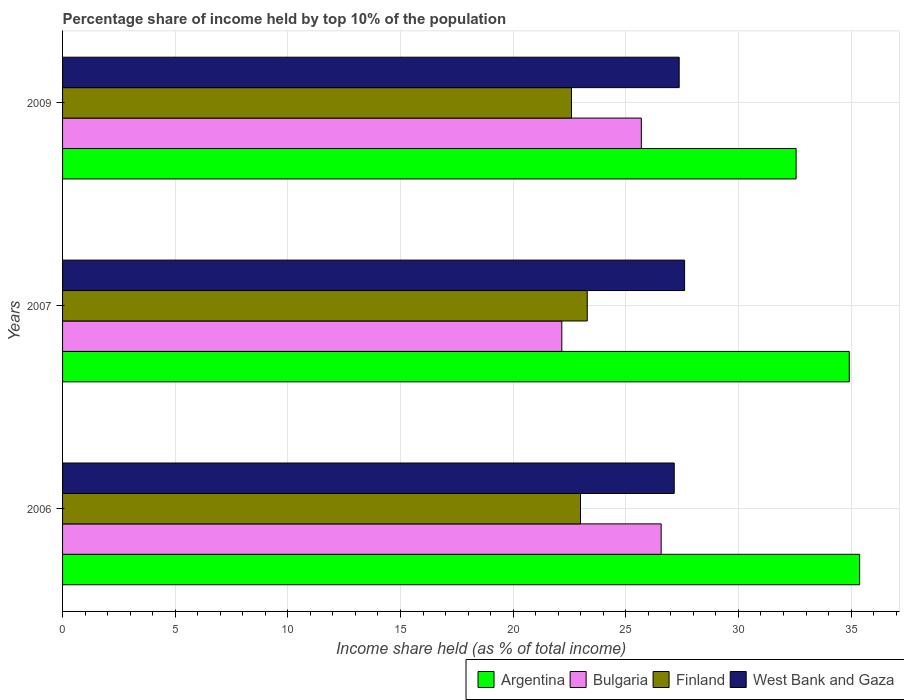How many different coloured bars are there?
Provide a succinct answer. 4. How many groups of bars are there?
Your response must be concise. 3. Are the number of bars per tick equal to the number of legend labels?
Provide a succinct answer. Yes. What is the label of the 3rd group of bars from the top?
Offer a terse response. 2006. What is the percentage share of income held by top 10% of the population in Argentina in 2006?
Your answer should be very brief. 35.38. Across all years, what is the maximum percentage share of income held by top 10% of the population in Argentina?
Your response must be concise. 35.38. Across all years, what is the minimum percentage share of income held by top 10% of the population in Finland?
Ensure brevity in your answer.  22.59. In which year was the percentage share of income held by top 10% of the population in West Bank and Gaza maximum?
Provide a succinct answer. 2007. In which year was the percentage share of income held by top 10% of the population in Finland minimum?
Offer a terse response. 2009. What is the total percentage share of income held by top 10% of the population in West Bank and Gaza in the graph?
Your answer should be very brief. 82.13. What is the difference between the percentage share of income held by top 10% of the population in Finland in 2006 and that in 2007?
Keep it short and to the point. -0.3. What is the difference between the percentage share of income held by top 10% of the population in West Bank and Gaza in 2006 and the percentage share of income held by top 10% of the population in Argentina in 2009?
Offer a terse response. -5.41. What is the average percentage share of income held by top 10% of the population in Argentina per year?
Keep it short and to the point. 34.29. In the year 2009, what is the difference between the percentage share of income held by top 10% of the population in Bulgaria and percentage share of income held by top 10% of the population in Finland?
Ensure brevity in your answer.  3.1. What is the ratio of the percentage share of income held by top 10% of the population in Bulgaria in 2006 to that in 2009?
Provide a succinct answer. 1.03. Is the difference between the percentage share of income held by top 10% of the population in Bulgaria in 2006 and 2009 greater than the difference between the percentage share of income held by top 10% of the population in Finland in 2006 and 2009?
Provide a succinct answer. Yes. What is the difference between the highest and the second highest percentage share of income held by top 10% of the population in Bulgaria?
Keep it short and to the point. 0.88. What is the difference between the highest and the lowest percentage share of income held by top 10% of the population in Finland?
Make the answer very short. 0.7. In how many years, is the percentage share of income held by top 10% of the population in Bulgaria greater than the average percentage share of income held by top 10% of the population in Bulgaria taken over all years?
Provide a succinct answer. 2. What does the 4th bar from the bottom in 2006 represents?
Give a very brief answer. West Bank and Gaza. How many bars are there?
Make the answer very short. 12. Are all the bars in the graph horizontal?
Provide a succinct answer. Yes. Does the graph contain grids?
Your answer should be very brief. Yes. Where does the legend appear in the graph?
Your answer should be compact. Bottom right. How many legend labels are there?
Offer a terse response. 4. What is the title of the graph?
Your answer should be very brief. Percentage share of income held by top 10% of the population. Does "Uzbekistan" appear as one of the legend labels in the graph?
Offer a terse response. No. What is the label or title of the X-axis?
Give a very brief answer. Income share held (as % of total income). What is the label or title of the Y-axis?
Your answer should be very brief. Years. What is the Income share held (as % of total income) of Argentina in 2006?
Your answer should be very brief. 35.38. What is the Income share held (as % of total income) in Bulgaria in 2006?
Provide a short and direct response. 26.57. What is the Income share held (as % of total income) in Finland in 2006?
Offer a terse response. 22.99. What is the Income share held (as % of total income) of West Bank and Gaza in 2006?
Your answer should be very brief. 27.15. What is the Income share held (as % of total income) of Argentina in 2007?
Ensure brevity in your answer.  34.92. What is the Income share held (as % of total income) in Bulgaria in 2007?
Make the answer very short. 22.16. What is the Income share held (as % of total income) of Finland in 2007?
Give a very brief answer. 23.29. What is the Income share held (as % of total income) of West Bank and Gaza in 2007?
Make the answer very short. 27.61. What is the Income share held (as % of total income) in Argentina in 2009?
Provide a succinct answer. 32.56. What is the Income share held (as % of total income) of Bulgaria in 2009?
Offer a terse response. 25.69. What is the Income share held (as % of total income) of Finland in 2009?
Offer a terse response. 22.59. What is the Income share held (as % of total income) of West Bank and Gaza in 2009?
Offer a very short reply. 27.37. Across all years, what is the maximum Income share held (as % of total income) of Argentina?
Ensure brevity in your answer.  35.38. Across all years, what is the maximum Income share held (as % of total income) in Bulgaria?
Your answer should be very brief. 26.57. Across all years, what is the maximum Income share held (as % of total income) of Finland?
Provide a succinct answer. 23.29. Across all years, what is the maximum Income share held (as % of total income) of West Bank and Gaza?
Make the answer very short. 27.61. Across all years, what is the minimum Income share held (as % of total income) of Argentina?
Your answer should be compact. 32.56. Across all years, what is the minimum Income share held (as % of total income) of Bulgaria?
Provide a short and direct response. 22.16. Across all years, what is the minimum Income share held (as % of total income) of Finland?
Offer a very short reply. 22.59. Across all years, what is the minimum Income share held (as % of total income) of West Bank and Gaza?
Your response must be concise. 27.15. What is the total Income share held (as % of total income) in Argentina in the graph?
Keep it short and to the point. 102.86. What is the total Income share held (as % of total income) of Bulgaria in the graph?
Your answer should be very brief. 74.42. What is the total Income share held (as % of total income) of Finland in the graph?
Provide a succinct answer. 68.87. What is the total Income share held (as % of total income) in West Bank and Gaza in the graph?
Ensure brevity in your answer.  82.13. What is the difference between the Income share held (as % of total income) of Argentina in 2006 and that in 2007?
Make the answer very short. 0.46. What is the difference between the Income share held (as % of total income) in Bulgaria in 2006 and that in 2007?
Make the answer very short. 4.41. What is the difference between the Income share held (as % of total income) of Finland in 2006 and that in 2007?
Your response must be concise. -0.3. What is the difference between the Income share held (as % of total income) of West Bank and Gaza in 2006 and that in 2007?
Your response must be concise. -0.46. What is the difference between the Income share held (as % of total income) of Argentina in 2006 and that in 2009?
Give a very brief answer. 2.82. What is the difference between the Income share held (as % of total income) of Finland in 2006 and that in 2009?
Provide a succinct answer. 0.4. What is the difference between the Income share held (as % of total income) in West Bank and Gaza in 2006 and that in 2009?
Ensure brevity in your answer.  -0.22. What is the difference between the Income share held (as % of total income) in Argentina in 2007 and that in 2009?
Ensure brevity in your answer.  2.36. What is the difference between the Income share held (as % of total income) in Bulgaria in 2007 and that in 2009?
Your response must be concise. -3.53. What is the difference between the Income share held (as % of total income) in West Bank and Gaza in 2007 and that in 2009?
Make the answer very short. 0.24. What is the difference between the Income share held (as % of total income) of Argentina in 2006 and the Income share held (as % of total income) of Bulgaria in 2007?
Your response must be concise. 13.22. What is the difference between the Income share held (as % of total income) in Argentina in 2006 and the Income share held (as % of total income) in Finland in 2007?
Your response must be concise. 12.09. What is the difference between the Income share held (as % of total income) of Argentina in 2006 and the Income share held (as % of total income) of West Bank and Gaza in 2007?
Offer a very short reply. 7.77. What is the difference between the Income share held (as % of total income) of Bulgaria in 2006 and the Income share held (as % of total income) of Finland in 2007?
Ensure brevity in your answer.  3.28. What is the difference between the Income share held (as % of total income) in Bulgaria in 2006 and the Income share held (as % of total income) in West Bank and Gaza in 2007?
Ensure brevity in your answer.  -1.04. What is the difference between the Income share held (as % of total income) of Finland in 2006 and the Income share held (as % of total income) of West Bank and Gaza in 2007?
Offer a terse response. -4.62. What is the difference between the Income share held (as % of total income) of Argentina in 2006 and the Income share held (as % of total income) of Bulgaria in 2009?
Offer a very short reply. 9.69. What is the difference between the Income share held (as % of total income) of Argentina in 2006 and the Income share held (as % of total income) of Finland in 2009?
Your response must be concise. 12.79. What is the difference between the Income share held (as % of total income) of Argentina in 2006 and the Income share held (as % of total income) of West Bank and Gaza in 2009?
Make the answer very short. 8.01. What is the difference between the Income share held (as % of total income) of Bulgaria in 2006 and the Income share held (as % of total income) of Finland in 2009?
Offer a very short reply. 3.98. What is the difference between the Income share held (as % of total income) of Bulgaria in 2006 and the Income share held (as % of total income) of West Bank and Gaza in 2009?
Your answer should be very brief. -0.8. What is the difference between the Income share held (as % of total income) in Finland in 2006 and the Income share held (as % of total income) in West Bank and Gaza in 2009?
Provide a short and direct response. -4.38. What is the difference between the Income share held (as % of total income) of Argentina in 2007 and the Income share held (as % of total income) of Bulgaria in 2009?
Ensure brevity in your answer.  9.23. What is the difference between the Income share held (as % of total income) of Argentina in 2007 and the Income share held (as % of total income) of Finland in 2009?
Offer a terse response. 12.33. What is the difference between the Income share held (as % of total income) in Argentina in 2007 and the Income share held (as % of total income) in West Bank and Gaza in 2009?
Make the answer very short. 7.55. What is the difference between the Income share held (as % of total income) of Bulgaria in 2007 and the Income share held (as % of total income) of Finland in 2009?
Your answer should be very brief. -0.43. What is the difference between the Income share held (as % of total income) of Bulgaria in 2007 and the Income share held (as % of total income) of West Bank and Gaza in 2009?
Make the answer very short. -5.21. What is the difference between the Income share held (as % of total income) of Finland in 2007 and the Income share held (as % of total income) of West Bank and Gaza in 2009?
Your answer should be very brief. -4.08. What is the average Income share held (as % of total income) of Argentina per year?
Ensure brevity in your answer.  34.29. What is the average Income share held (as % of total income) in Bulgaria per year?
Give a very brief answer. 24.81. What is the average Income share held (as % of total income) of Finland per year?
Offer a very short reply. 22.96. What is the average Income share held (as % of total income) of West Bank and Gaza per year?
Make the answer very short. 27.38. In the year 2006, what is the difference between the Income share held (as % of total income) in Argentina and Income share held (as % of total income) in Bulgaria?
Your answer should be compact. 8.81. In the year 2006, what is the difference between the Income share held (as % of total income) of Argentina and Income share held (as % of total income) of Finland?
Provide a short and direct response. 12.39. In the year 2006, what is the difference between the Income share held (as % of total income) in Argentina and Income share held (as % of total income) in West Bank and Gaza?
Your response must be concise. 8.23. In the year 2006, what is the difference between the Income share held (as % of total income) of Bulgaria and Income share held (as % of total income) of Finland?
Your response must be concise. 3.58. In the year 2006, what is the difference between the Income share held (as % of total income) in Bulgaria and Income share held (as % of total income) in West Bank and Gaza?
Keep it short and to the point. -0.58. In the year 2006, what is the difference between the Income share held (as % of total income) of Finland and Income share held (as % of total income) of West Bank and Gaza?
Offer a very short reply. -4.16. In the year 2007, what is the difference between the Income share held (as % of total income) of Argentina and Income share held (as % of total income) of Bulgaria?
Your answer should be very brief. 12.76. In the year 2007, what is the difference between the Income share held (as % of total income) of Argentina and Income share held (as % of total income) of Finland?
Make the answer very short. 11.63. In the year 2007, what is the difference between the Income share held (as % of total income) of Argentina and Income share held (as % of total income) of West Bank and Gaza?
Give a very brief answer. 7.31. In the year 2007, what is the difference between the Income share held (as % of total income) of Bulgaria and Income share held (as % of total income) of Finland?
Your answer should be very brief. -1.13. In the year 2007, what is the difference between the Income share held (as % of total income) in Bulgaria and Income share held (as % of total income) in West Bank and Gaza?
Ensure brevity in your answer.  -5.45. In the year 2007, what is the difference between the Income share held (as % of total income) in Finland and Income share held (as % of total income) in West Bank and Gaza?
Give a very brief answer. -4.32. In the year 2009, what is the difference between the Income share held (as % of total income) of Argentina and Income share held (as % of total income) of Bulgaria?
Provide a short and direct response. 6.87. In the year 2009, what is the difference between the Income share held (as % of total income) of Argentina and Income share held (as % of total income) of Finland?
Keep it short and to the point. 9.97. In the year 2009, what is the difference between the Income share held (as % of total income) of Argentina and Income share held (as % of total income) of West Bank and Gaza?
Ensure brevity in your answer.  5.19. In the year 2009, what is the difference between the Income share held (as % of total income) of Bulgaria and Income share held (as % of total income) of Finland?
Keep it short and to the point. 3.1. In the year 2009, what is the difference between the Income share held (as % of total income) of Bulgaria and Income share held (as % of total income) of West Bank and Gaza?
Give a very brief answer. -1.68. In the year 2009, what is the difference between the Income share held (as % of total income) in Finland and Income share held (as % of total income) in West Bank and Gaza?
Ensure brevity in your answer.  -4.78. What is the ratio of the Income share held (as % of total income) in Argentina in 2006 to that in 2007?
Your response must be concise. 1.01. What is the ratio of the Income share held (as % of total income) of Bulgaria in 2006 to that in 2007?
Offer a terse response. 1.2. What is the ratio of the Income share held (as % of total income) of Finland in 2006 to that in 2007?
Your answer should be very brief. 0.99. What is the ratio of the Income share held (as % of total income) of West Bank and Gaza in 2006 to that in 2007?
Your answer should be very brief. 0.98. What is the ratio of the Income share held (as % of total income) of Argentina in 2006 to that in 2009?
Offer a very short reply. 1.09. What is the ratio of the Income share held (as % of total income) of Bulgaria in 2006 to that in 2009?
Make the answer very short. 1.03. What is the ratio of the Income share held (as % of total income) in Finland in 2006 to that in 2009?
Provide a short and direct response. 1.02. What is the ratio of the Income share held (as % of total income) in Argentina in 2007 to that in 2009?
Provide a succinct answer. 1.07. What is the ratio of the Income share held (as % of total income) of Bulgaria in 2007 to that in 2009?
Provide a succinct answer. 0.86. What is the ratio of the Income share held (as % of total income) in Finland in 2007 to that in 2009?
Keep it short and to the point. 1.03. What is the ratio of the Income share held (as % of total income) of West Bank and Gaza in 2007 to that in 2009?
Keep it short and to the point. 1.01. What is the difference between the highest and the second highest Income share held (as % of total income) of Argentina?
Ensure brevity in your answer.  0.46. What is the difference between the highest and the second highest Income share held (as % of total income) in Bulgaria?
Ensure brevity in your answer.  0.88. What is the difference between the highest and the second highest Income share held (as % of total income) in Finland?
Provide a succinct answer. 0.3. What is the difference between the highest and the second highest Income share held (as % of total income) in West Bank and Gaza?
Provide a short and direct response. 0.24. What is the difference between the highest and the lowest Income share held (as % of total income) of Argentina?
Give a very brief answer. 2.82. What is the difference between the highest and the lowest Income share held (as % of total income) in Bulgaria?
Ensure brevity in your answer.  4.41. What is the difference between the highest and the lowest Income share held (as % of total income) in Finland?
Your answer should be compact. 0.7. What is the difference between the highest and the lowest Income share held (as % of total income) in West Bank and Gaza?
Provide a short and direct response. 0.46. 